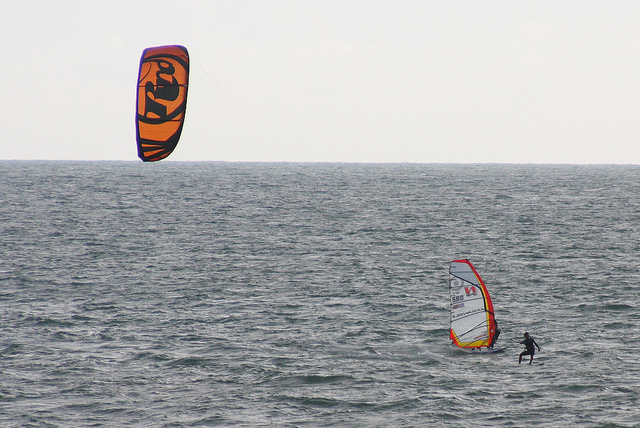Describe the atmosphere and the emotions this photo evokes. The photo evokes a sense of adventure and excitement. The vast expanse of the ocean, the wind in the sails, and the energy of the individuals engaging in these water sports create a thrilling atmosphere. One can almost feel the rush of adrenaline as the windsurfer cuts through the waves and the parasailor soars above. What might the weather conditions be like in this scene? The weather appears to be mild and conducive to water sports. The ocean looks relatively calm with a gentle breeze, perfect for both parasailing and windsurfing. There are no dark or heavy clouds in sight, suggesting it is a clear day with good visibility. If you could join in this scene, what would you choose to do and why? I would choose to try windsurfing because it seems like a thrilling experience that requires skill and balance. Riding the waves with the wind propelling you forward would be both challenging and exhilarating. Plus, getting up close and personal with the ocean, feeling the spray of the sea, and navigating through the water would be unforgettable. 